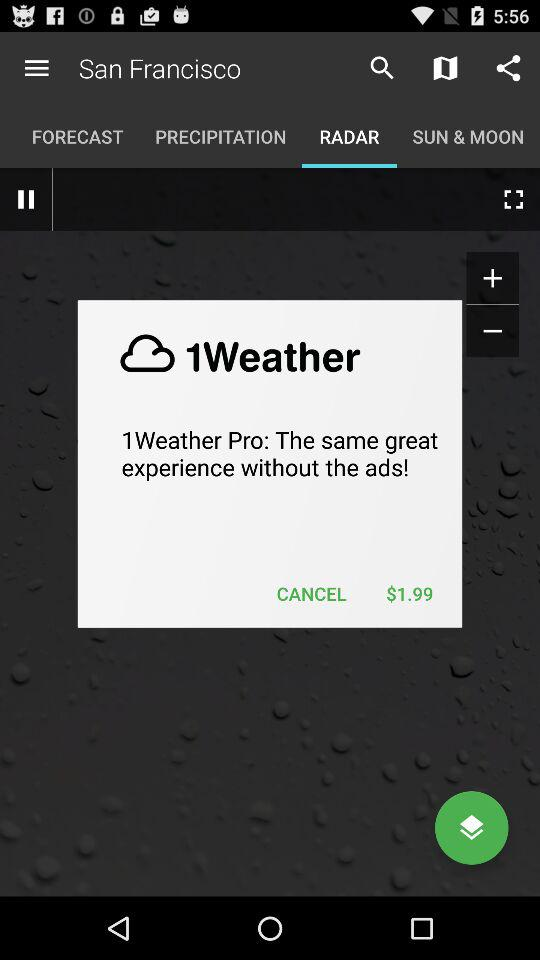What's the cost of the 1Weather Pro? The cost is $1.99. 